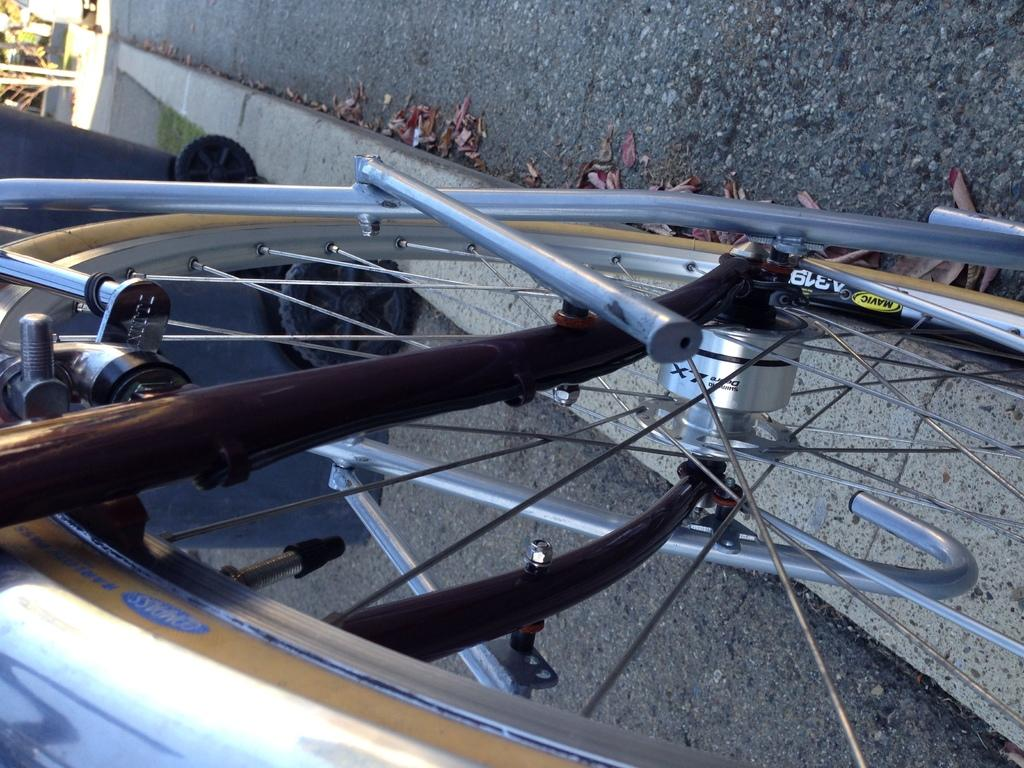What is the main object in the image? There is a bicycle frame in the image. What else can be seen in the image besides the bicycle frame? There are dried leaves in the image. What type of waste can be seen in the image? There is no waste present in the image; it features a bicycle frame and dried leaves. What discovery was made in the hall depicted in the image? There is no hall or any indication of a discovery in the image. 